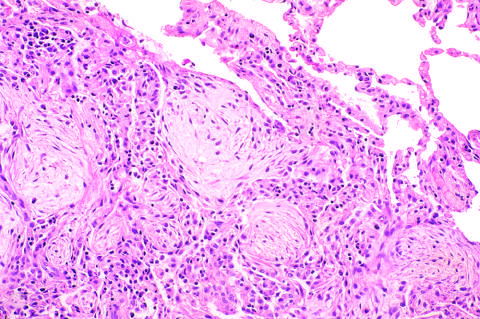what is infiltrated by macrophages and fibroblasts?
Answer the question using a single word or phrase. Fibromyxoid masses 